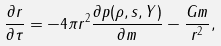Convert formula to latex. <formula><loc_0><loc_0><loc_500><loc_500>\frac { \partial r } { \partial \tau } = - 4 \pi r ^ { 2 } \frac { \partial p ( \rho , s , Y ) } { \partial m } - \frac { G m } { r ^ { 2 } } ,</formula> 